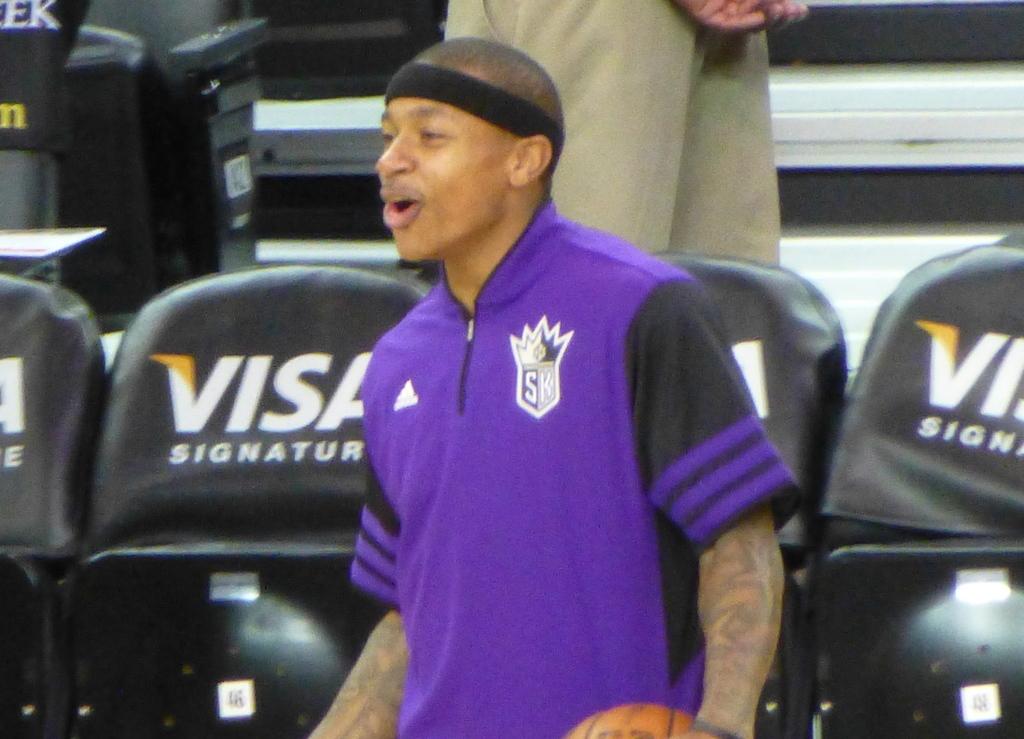What game is this man playing?
Make the answer very short. Basketball. 